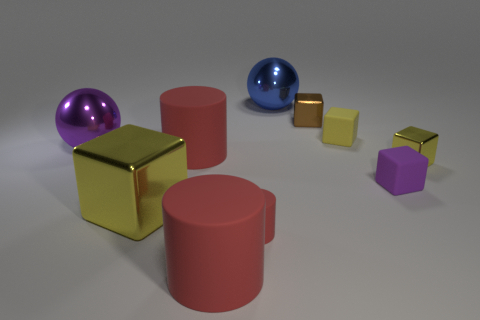How do the sizes of the objects compare to each other? There is a variety of sizes among the objects: the cylinders and the cubes come in distinctly different sizes, creating a sense of both symmetry and scale variation in this scene. 